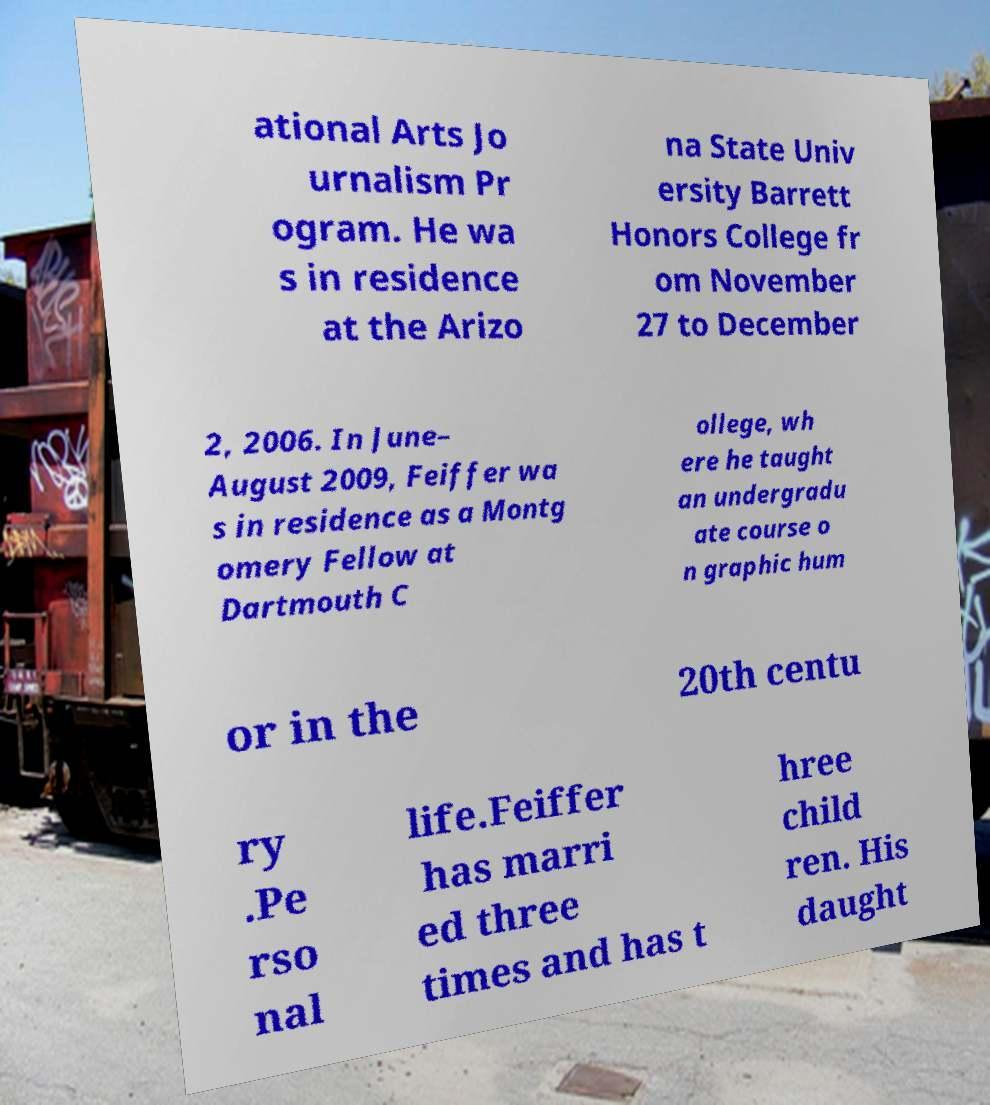For documentation purposes, I need the text within this image transcribed. Could you provide that? ational Arts Jo urnalism Pr ogram. He wa s in residence at the Arizo na State Univ ersity Barrett Honors College fr om November 27 to December 2, 2006. In June– August 2009, Feiffer wa s in residence as a Montg omery Fellow at Dartmouth C ollege, wh ere he taught an undergradu ate course o n graphic hum or in the 20th centu ry .Pe rso nal life.Feiffer has marri ed three times and has t hree child ren. His daught 